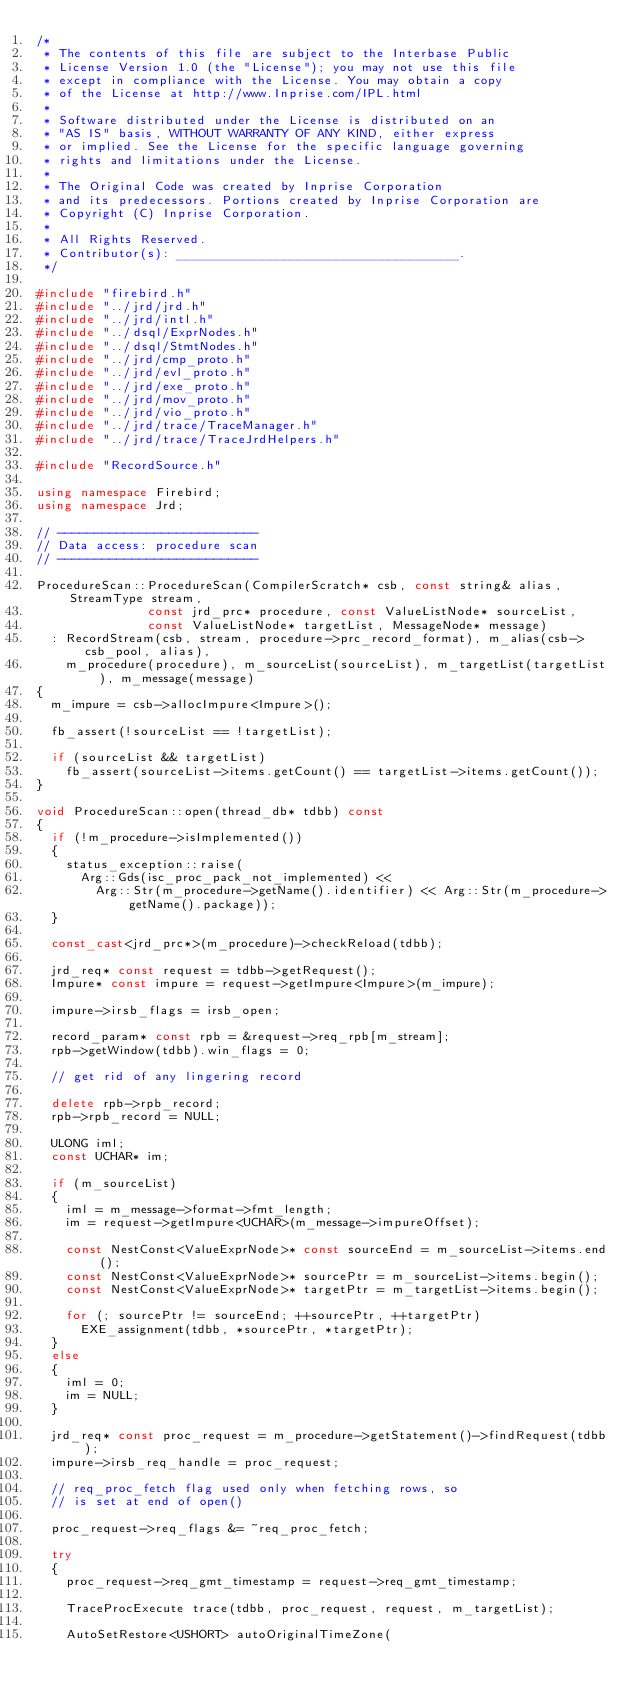<code> <loc_0><loc_0><loc_500><loc_500><_C++_>/*
 * The contents of this file are subject to the Interbase Public
 * License Version 1.0 (the "License"); you may not use this file
 * except in compliance with the License. You may obtain a copy
 * of the License at http://www.Inprise.com/IPL.html
 *
 * Software distributed under the License is distributed on an
 * "AS IS" basis, WITHOUT WARRANTY OF ANY KIND, either express
 * or implied. See the License for the specific language governing
 * rights and limitations under the License.
 *
 * The Original Code was created by Inprise Corporation
 * and its predecessors. Portions created by Inprise Corporation are
 * Copyright (C) Inprise Corporation.
 *
 * All Rights Reserved.
 * Contributor(s): ______________________________________.
 */

#include "firebird.h"
#include "../jrd/jrd.h"
#include "../jrd/intl.h"
#include "../dsql/ExprNodes.h"
#include "../dsql/StmtNodes.h"
#include "../jrd/cmp_proto.h"
#include "../jrd/evl_proto.h"
#include "../jrd/exe_proto.h"
#include "../jrd/mov_proto.h"
#include "../jrd/vio_proto.h"
#include "../jrd/trace/TraceManager.h"
#include "../jrd/trace/TraceJrdHelpers.h"

#include "RecordSource.h"

using namespace Firebird;
using namespace Jrd;

// ---------------------------
// Data access: procedure scan
// ---------------------------

ProcedureScan::ProcedureScan(CompilerScratch* csb, const string& alias, StreamType stream,
							 const jrd_prc* procedure, const ValueListNode* sourceList,
							 const ValueListNode* targetList, MessageNode* message)
	: RecordStream(csb, stream, procedure->prc_record_format), m_alias(csb->csb_pool, alias),
	  m_procedure(procedure), m_sourceList(sourceList), m_targetList(targetList), m_message(message)
{
	m_impure = csb->allocImpure<Impure>();

	fb_assert(!sourceList == !targetList);

	if (sourceList && targetList)
		fb_assert(sourceList->items.getCount() == targetList->items.getCount());
}

void ProcedureScan::open(thread_db* tdbb) const
{
	if (!m_procedure->isImplemented())
	{
		status_exception::raise(
			Arg::Gds(isc_proc_pack_not_implemented) <<
				Arg::Str(m_procedure->getName().identifier) << Arg::Str(m_procedure->getName().package));
	}

	const_cast<jrd_prc*>(m_procedure)->checkReload(tdbb);

	jrd_req* const request = tdbb->getRequest();
	Impure* const impure = request->getImpure<Impure>(m_impure);

	impure->irsb_flags = irsb_open;

	record_param* const rpb = &request->req_rpb[m_stream];
	rpb->getWindow(tdbb).win_flags = 0;

	// get rid of any lingering record

	delete rpb->rpb_record;
	rpb->rpb_record = NULL;

	ULONG iml;
	const UCHAR* im;

	if (m_sourceList)
	{
		iml = m_message->format->fmt_length;
		im = request->getImpure<UCHAR>(m_message->impureOffset);

		const NestConst<ValueExprNode>* const sourceEnd = m_sourceList->items.end();
		const NestConst<ValueExprNode>* sourcePtr = m_sourceList->items.begin();
		const NestConst<ValueExprNode>* targetPtr = m_targetList->items.begin();

		for (; sourcePtr != sourceEnd; ++sourcePtr, ++targetPtr)
			EXE_assignment(tdbb, *sourcePtr, *targetPtr);
	}
	else
	{
		iml = 0;
		im = NULL;
	}

	jrd_req* const proc_request = m_procedure->getStatement()->findRequest(tdbb);
	impure->irsb_req_handle = proc_request;

	// req_proc_fetch flag used only when fetching rows, so
	// is set at end of open()

	proc_request->req_flags &= ~req_proc_fetch;

	try
	{
		proc_request->req_gmt_timestamp = request->req_gmt_timestamp;

		TraceProcExecute trace(tdbb, proc_request, request, m_targetList);

		AutoSetRestore<USHORT> autoOriginalTimeZone(</code> 